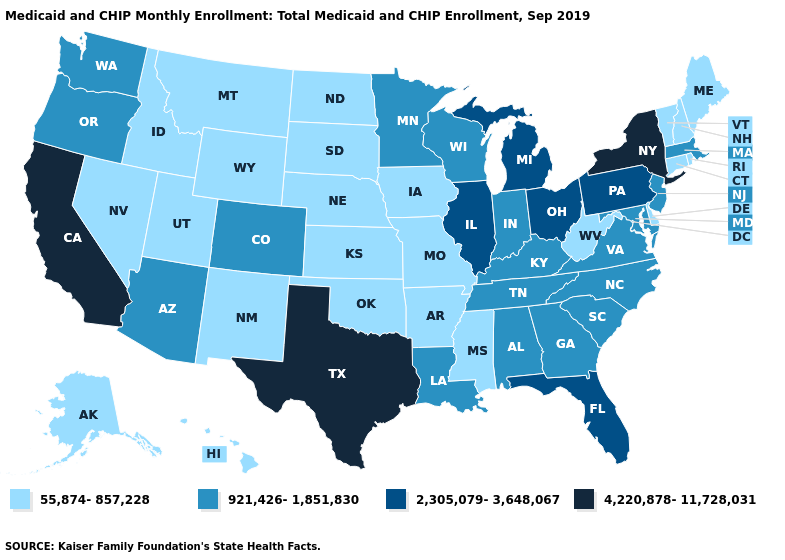Among the states that border Ohio , which have the lowest value?
Concise answer only. West Virginia. Name the states that have a value in the range 2,305,079-3,648,067?
Give a very brief answer. Florida, Illinois, Michigan, Ohio, Pennsylvania. What is the highest value in the Northeast ?
Quick response, please. 4,220,878-11,728,031. Is the legend a continuous bar?
Answer briefly. No. Name the states that have a value in the range 55,874-857,228?
Write a very short answer. Alaska, Arkansas, Connecticut, Delaware, Hawaii, Idaho, Iowa, Kansas, Maine, Mississippi, Missouri, Montana, Nebraska, Nevada, New Hampshire, New Mexico, North Dakota, Oklahoma, Rhode Island, South Dakota, Utah, Vermont, West Virginia, Wyoming. Name the states that have a value in the range 4,220,878-11,728,031?
Write a very short answer. California, New York, Texas. What is the value of Tennessee?
Be succinct. 921,426-1,851,830. Name the states that have a value in the range 55,874-857,228?
Be succinct. Alaska, Arkansas, Connecticut, Delaware, Hawaii, Idaho, Iowa, Kansas, Maine, Mississippi, Missouri, Montana, Nebraska, Nevada, New Hampshire, New Mexico, North Dakota, Oklahoma, Rhode Island, South Dakota, Utah, Vermont, West Virginia, Wyoming. Does Florida have the lowest value in the USA?
Keep it brief. No. Among the states that border Colorado , which have the highest value?
Keep it brief. Arizona. What is the highest value in the MidWest ?
Give a very brief answer. 2,305,079-3,648,067. What is the highest value in states that border Oklahoma?
Short answer required. 4,220,878-11,728,031. Does the first symbol in the legend represent the smallest category?
Short answer required. Yes. Does New York have the highest value in the Northeast?
Be succinct. Yes. 